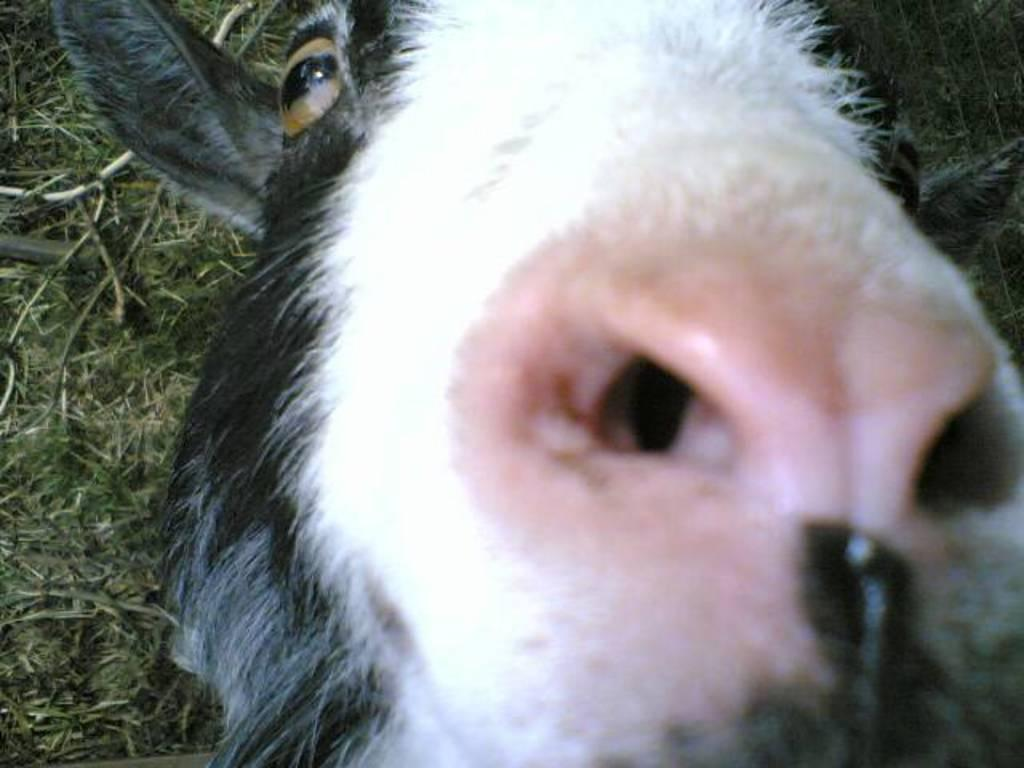What type of animal is in the image? The type of animal cannot be determined from the provided facts. What can be seen in the background of the image? There is grass in the background of the image. What type of fuel is being used by the railway in the image? There is no railway present in the image, so it is not possible to determine what type of fuel is being used. 